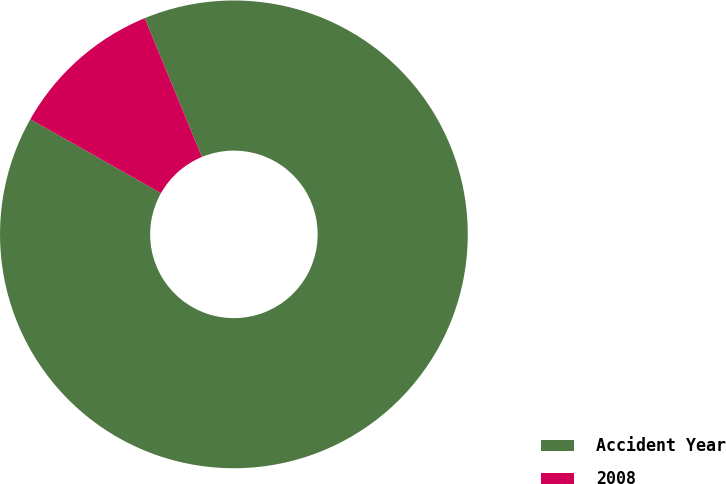<chart> <loc_0><loc_0><loc_500><loc_500><pie_chart><fcel>Accident Year<fcel>2008<nl><fcel>89.42%<fcel>10.58%<nl></chart> 